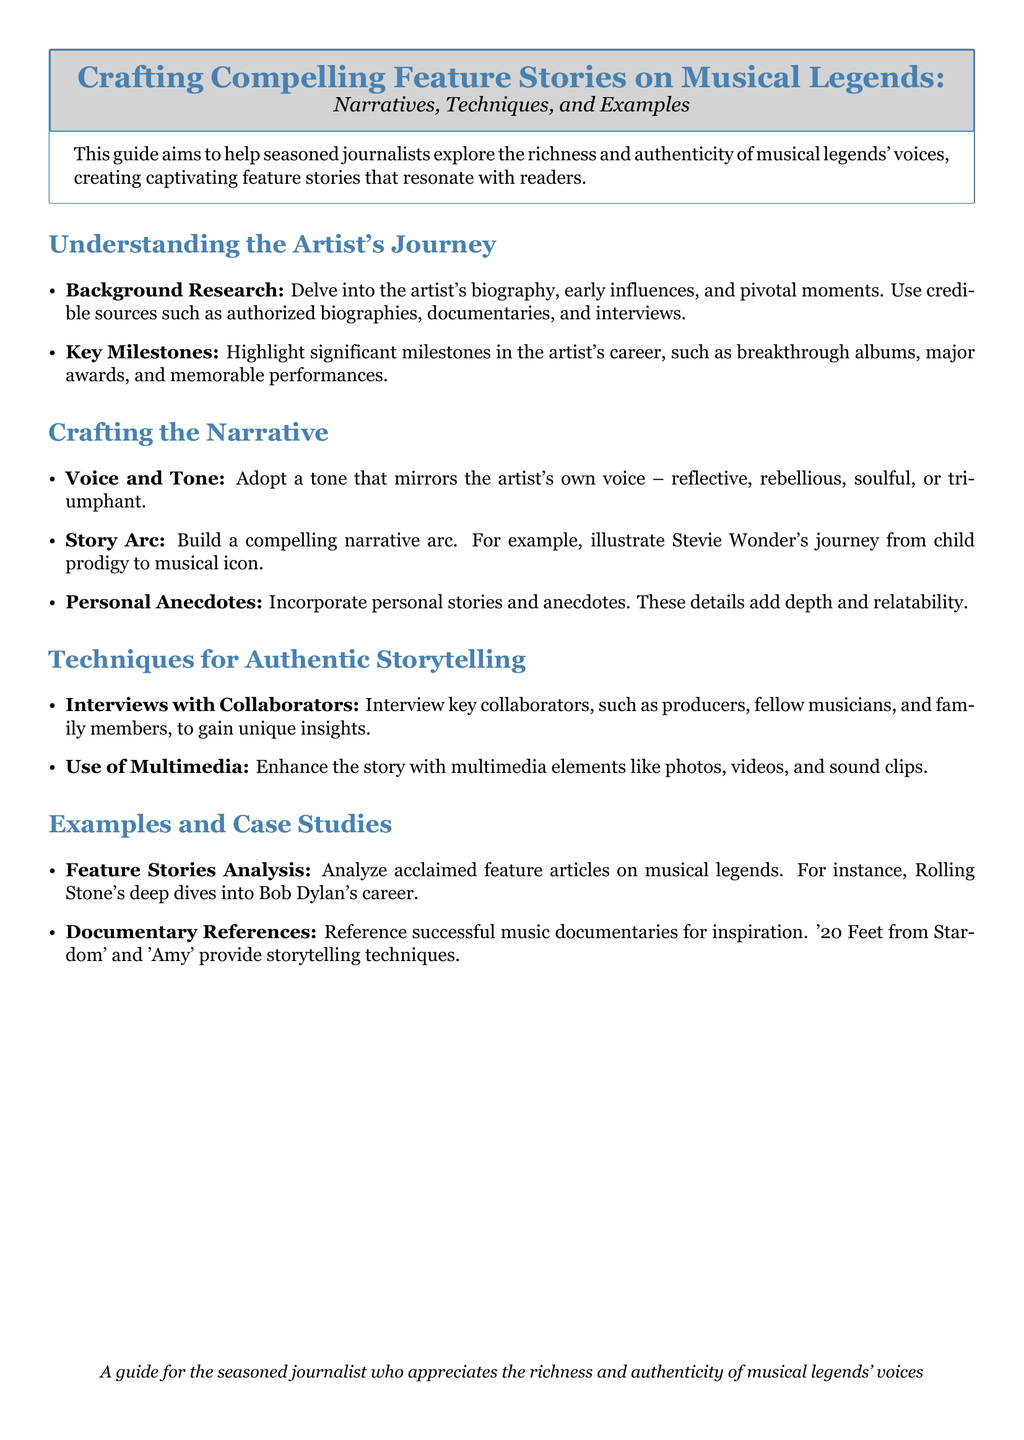what is the main purpose of the guide? The guide aims to help seasoned journalists explore the richness and authenticity of musical legends' voices, creating captivating feature stories that resonate with readers.
Answer: help seasoned journalists what type of sources are recommended for background research? The document suggests using credible sources such as authorized biographies, documentaries, and interviews for background research.
Answer: authorized biographies, documentaries, and interviews name one of the storytelling techniques suggested. The guide mentions interviewing key collaborators as a technique for authentic storytelling.
Answer: interviewing key collaborators who is mentioned as an example of an artist to illustrate a narrative arc? The document provides Stevie Wonder as an example of an artist whose journey can be illustrated in a narrative arc.
Answer: Stevie Wonder what are two documentaries referenced for inspiration? The guide refers to '20 Feet from Stardom' and 'Amy' as successful music documentaries for storytelling techniques.
Answer: '20 Feet from Stardom' and 'Amy' how should the narrative tone reflect the artist? The narrative tone should mirror the artist's own voice, which can be reflective, rebellious, soulful, or triumphant.
Answer: reflective, rebellious, soulful, or triumphant what is the recommended first step in understanding an artist's journey? Delving into the artist's biography is the recommended first step in understanding their journey.
Answer: delving into the artist's biography 